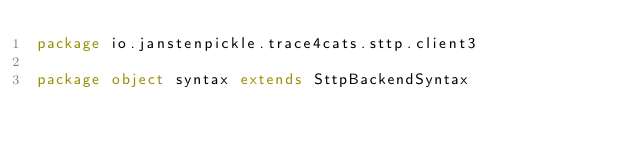Convert code to text. <code><loc_0><loc_0><loc_500><loc_500><_Scala_>package io.janstenpickle.trace4cats.sttp.client3

package object syntax extends SttpBackendSyntax
</code> 